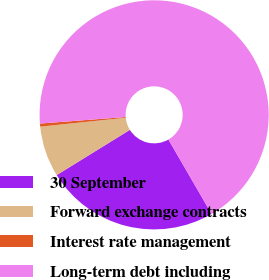Convert chart. <chart><loc_0><loc_0><loc_500><loc_500><pie_chart><fcel>30 September<fcel>Forward exchange contracts<fcel>Interest rate management<fcel>Long-term debt including<nl><fcel>24.55%<fcel>7.17%<fcel>0.43%<fcel>67.85%<nl></chart> 